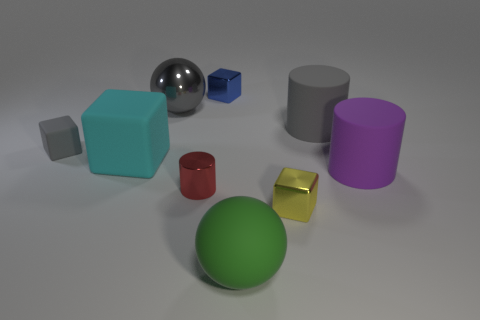What material is the blue block? The blue block appears to be made of a plastic material with a matte finish, commonly used for educational or children's building blocks. 